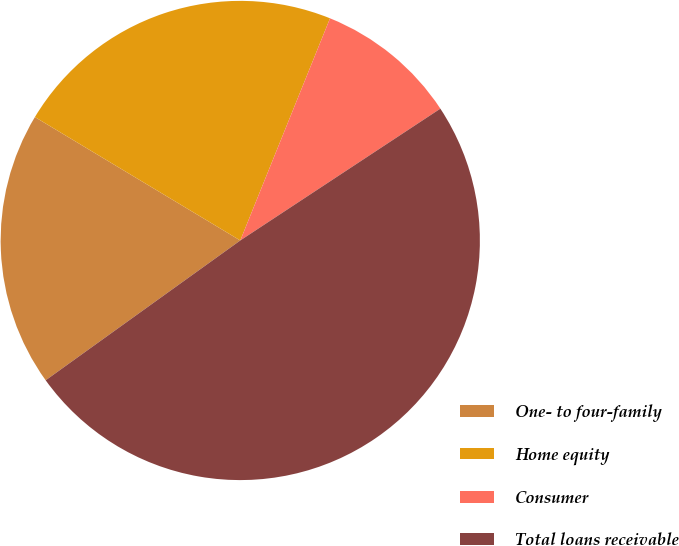<chart> <loc_0><loc_0><loc_500><loc_500><pie_chart><fcel>One- to four-family<fcel>Home equity<fcel>Consumer<fcel>Total loans receivable<nl><fcel>18.53%<fcel>22.5%<fcel>9.62%<fcel>49.36%<nl></chart> 